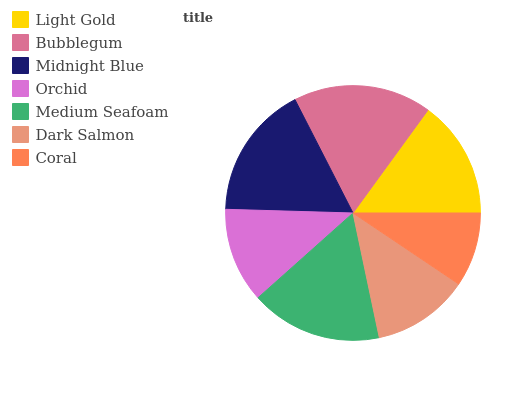Is Coral the minimum?
Answer yes or no. Yes. Is Bubblegum the maximum?
Answer yes or no. Yes. Is Midnight Blue the minimum?
Answer yes or no. No. Is Midnight Blue the maximum?
Answer yes or no. No. Is Bubblegum greater than Midnight Blue?
Answer yes or no. Yes. Is Midnight Blue less than Bubblegum?
Answer yes or no. Yes. Is Midnight Blue greater than Bubblegum?
Answer yes or no. No. Is Bubblegum less than Midnight Blue?
Answer yes or no. No. Is Light Gold the high median?
Answer yes or no. Yes. Is Light Gold the low median?
Answer yes or no. Yes. Is Medium Seafoam the high median?
Answer yes or no. No. Is Orchid the low median?
Answer yes or no. No. 